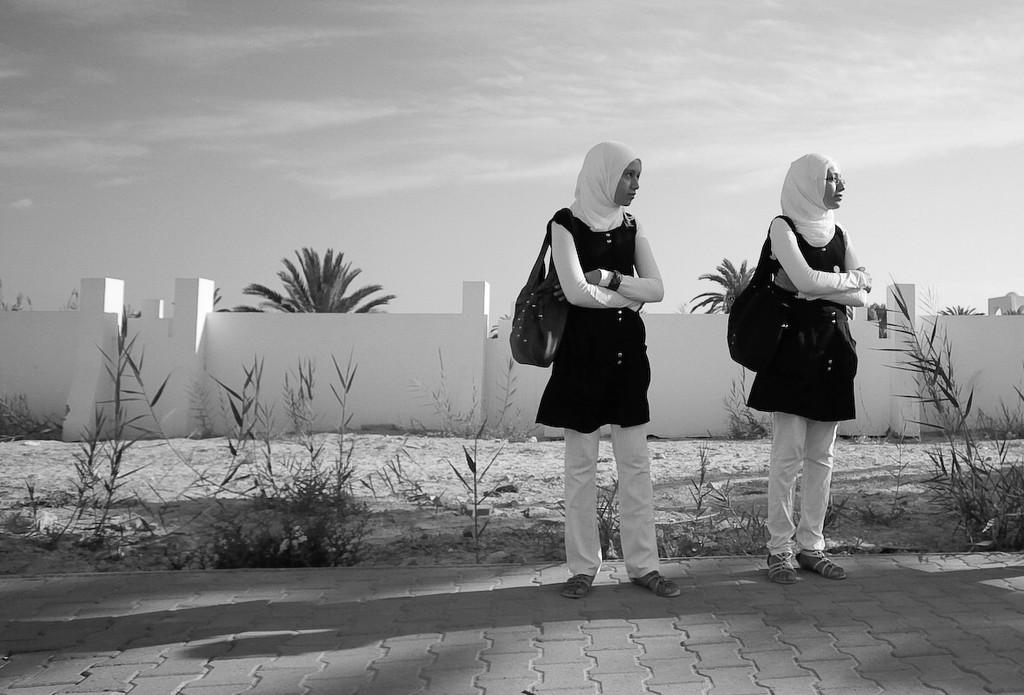Could you give a brief overview of what you see in this image? In this picture there are two girls on the right side of the image and there is wall in the background area of the image and there are trees behind the wall. 